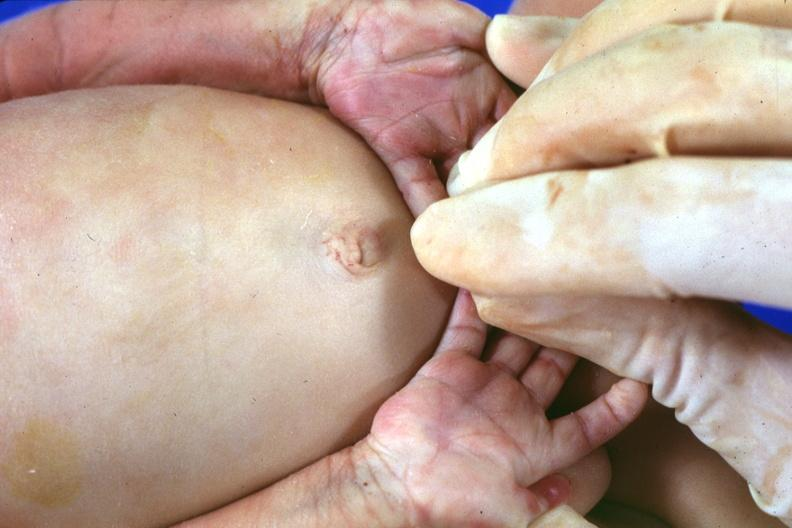re extremities present?
Answer the question using a single word or phrase. Yes 